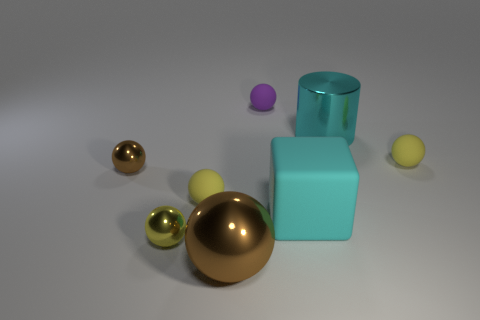Subtract all purple rubber balls. How many balls are left? 5 Subtract all purple balls. How many balls are left? 5 Subtract 1 spheres. How many spheres are left? 5 Add 1 tiny purple objects. How many objects exist? 9 Subtract all balls. How many objects are left? 2 Subtract all purple balls. Subtract all blue blocks. How many balls are left? 5 Subtract all purple balls. How many blue blocks are left? 0 Subtract all tiny yellow shiny objects. Subtract all brown rubber spheres. How many objects are left? 7 Add 4 big things. How many big things are left? 7 Add 7 big cyan blocks. How many big cyan blocks exist? 8 